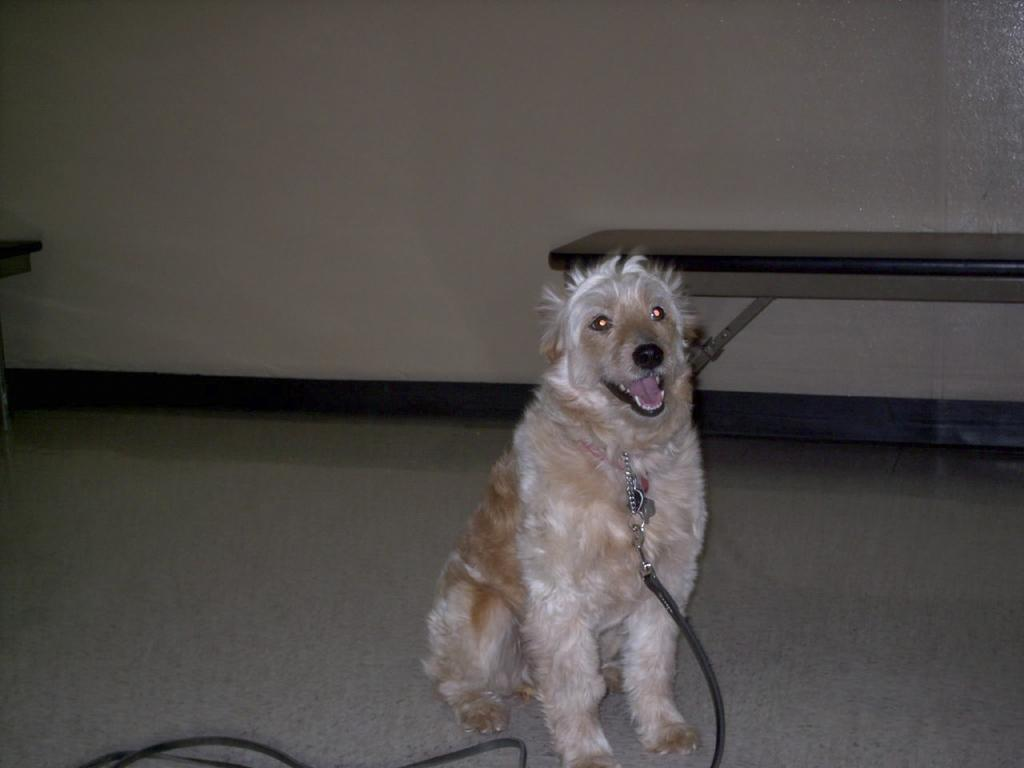What type of animal is in the picture? There is a dog in the picture. What is attached to the dog? The dog has a belt tightened to it. Can you describe any other objects or structures in the image? There is a bench in the right corner of the image. What color is the sky in the image? There is no sky visible in the image, as it is focused on the dog and the bench. Can you see a needle in the image? There is no needle present in the image. 